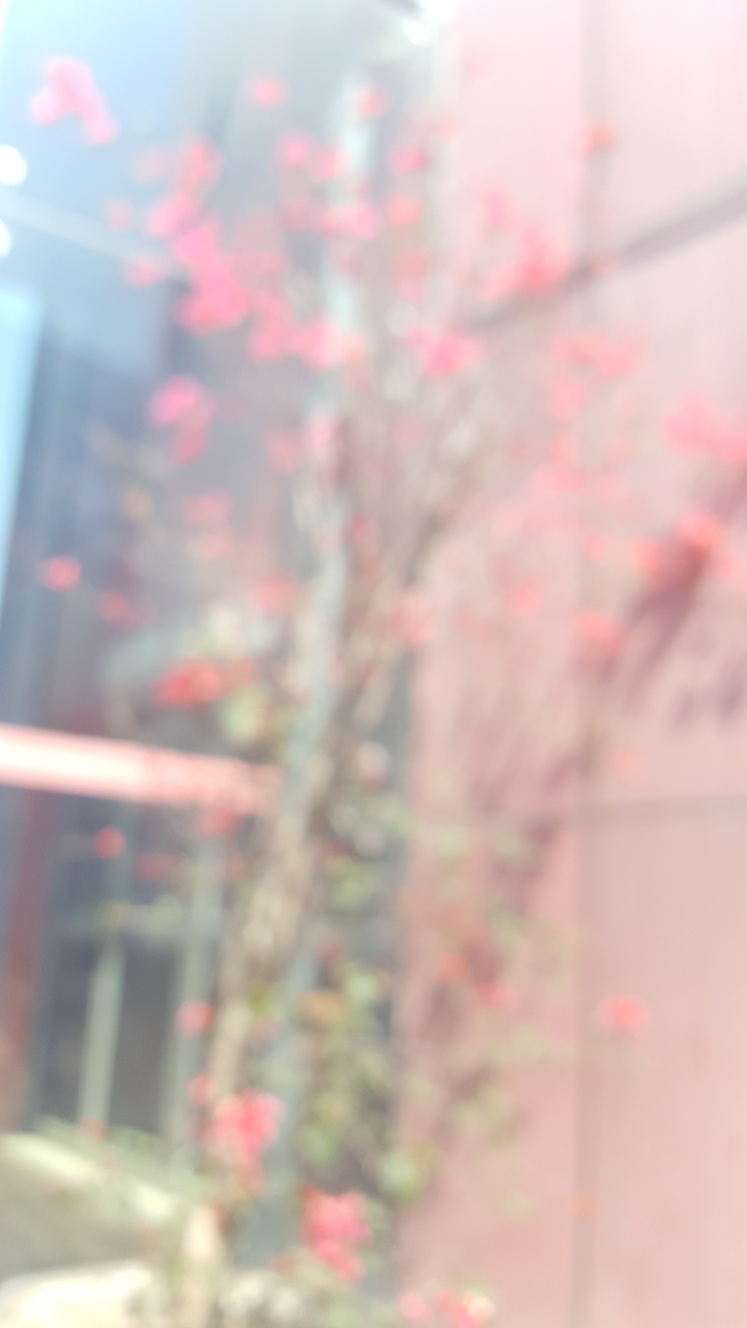What does the blurred background tell us about the context in which this photo was taken? The blurred background in the photograph suggests a shallow depth of field, which is often used to highlight the subject by softening the surroundings. This technique allows the tree and its blossoms to draw the viewer's attention and can imply that the photograph was taken in an urban or garden setting where the photographer wished to isolate the beauty of the tree from any distractions in the background. Could you infer anything about the weather or time of day when this photo was taken? While the details are not sharply defined due to the blurring effect, the lighting appears soft and diffuse, which can indicate an overcast sky or perhaps the photo was taken during the early morning or late afternoon hours when the sunlight is not as harsh. The lack of shadows and the gentle light give the scene a tranquil, serene quality. 